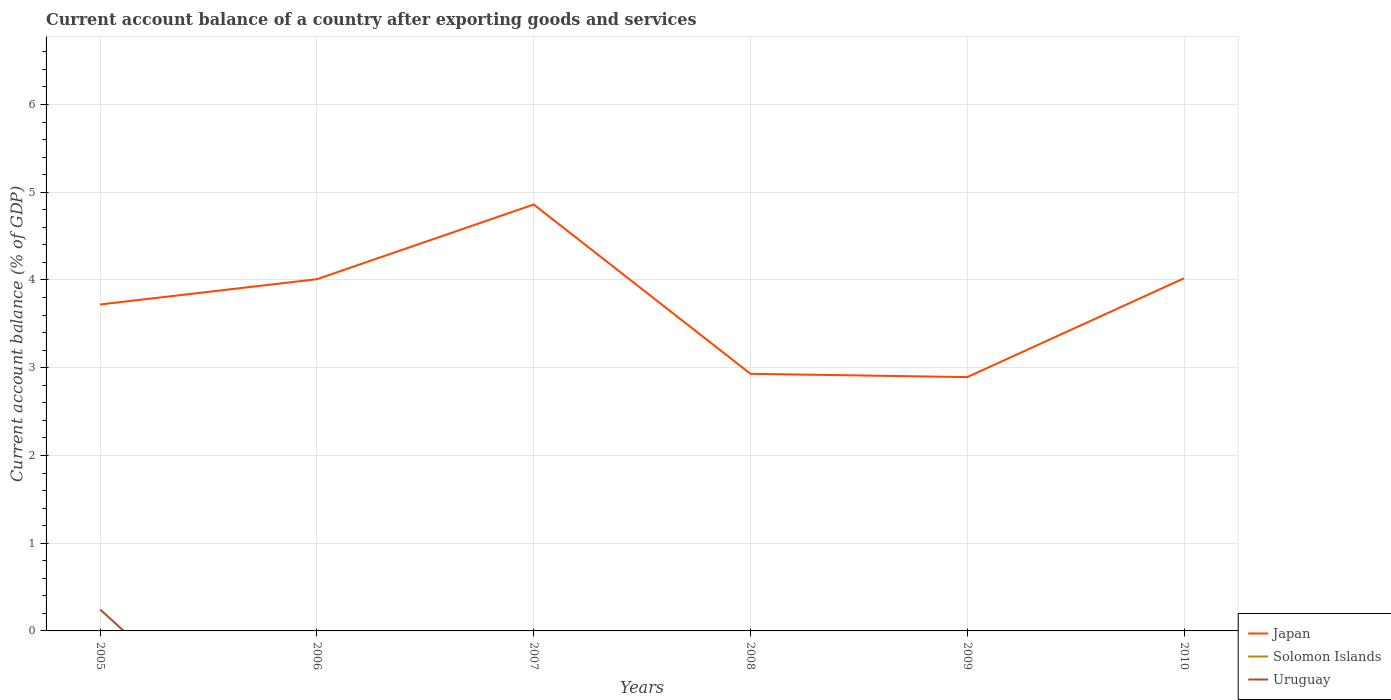How many different coloured lines are there?
Keep it short and to the point. 2. Does the line corresponding to Uruguay intersect with the line corresponding to Solomon Islands?
Your answer should be compact. No. Across all years, what is the maximum account balance in Uruguay?
Ensure brevity in your answer.  0. What is the total account balance in Japan in the graph?
Provide a succinct answer. 0.04. What is the difference between the highest and the second highest account balance in Japan?
Offer a very short reply. 1.97. Does the graph contain any zero values?
Your answer should be very brief. Yes. Does the graph contain grids?
Make the answer very short. Yes. How are the legend labels stacked?
Your answer should be compact. Vertical. What is the title of the graph?
Provide a short and direct response. Current account balance of a country after exporting goods and services. What is the label or title of the Y-axis?
Give a very brief answer. Current account balance (% of GDP). What is the Current account balance (% of GDP) in Japan in 2005?
Ensure brevity in your answer.  3.72. What is the Current account balance (% of GDP) in Uruguay in 2005?
Offer a very short reply. 0.24. What is the Current account balance (% of GDP) of Japan in 2006?
Ensure brevity in your answer.  4.01. What is the Current account balance (% of GDP) of Solomon Islands in 2006?
Give a very brief answer. 0. What is the Current account balance (% of GDP) in Uruguay in 2006?
Keep it short and to the point. 0. What is the Current account balance (% of GDP) in Japan in 2007?
Provide a succinct answer. 4.86. What is the Current account balance (% of GDP) in Uruguay in 2007?
Your response must be concise. 0. What is the Current account balance (% of GDP) in Japan in 2008?
Offer a terse response. 2.93. What is the Current account balance (% of GDP) in Japan in 2009?
Provide a succinct answer. 2.89. What is the Current account balance (% of GDP) in Uruguay in 2009?
Your answer should be very brief. 0. What is the Current account balance (% of GDP) of Japan in 2010?
Ensure brevity in your answer.  4.02. Across all years, what is the maximum Current account balance (% of GDP) of Japan?
Offer a terse response. 4.86. Across all years, what is the maximum Current account balance (% of GDP) in Uruguay?
Provide a succinct answer. 0.24. Across all years, what is the minimum Current account balance (% of GDP) of Japan?
Make the answer very short. 2.89. Across all years, what is the minimum Current account balance (% of GDP) in Uruguay?
Keep it short and to the point. 0. What is the total Current account balance (% of GDP) of Japan in the graph?
Give a very brief answer. 22.43. What is the total Current account balance (% of GDP) in Solomon Islands in the graph?
Offer a very short reply. 0. What is the total Current account balance (% of GDP) in Uruguay in the graph?
Your answer should be very brief. 0.24. What is the difference between the Current account balance (% of GDP) in Japan in 2005 and that in 2006?
Provide a succinct answer. -0.29. What is the difference between the Current account balance (% of GDP) of Japan in 2005 and that in 2007?
Provide a short and direct response. -1.14. What is the difference between the Current account balance (% of GDP) in Japan in 2005 and that in 2008?
Your answer should be very brief. 0.79. What is the difference between the Current account balance (% of GDP) in Japan in 2005 and that in 2009?
Your answer should be compact. 0.83. What is the difference between the Current account balance (% of GDP) of Japan in 2005 and that in 2010?
Offer a terse response. -0.3. What is the difference between the Current account balance (% of GDP) of Japan in 2006 and that in 2007?
Ensure brevity in your answer.  -0.85. What is the difference between the Current account balance (% of GDP) of Japan in 2006 and that in 2008?
Ensure brevity in your answer.  1.08. What is the difference between the Current account balance (% of GDP) in Japan in 2006 and that in 2009?
Keep it short and to the point. 1.12. What is the difference between the Current account balance (% of GDP) in Japan in 2006 and that in 2010?
Provide a short and direct response. -0.01. What is the difference between the Current account balance (% of GDP) in Japan in 2007 and that in 2008?
Your response must be concise. 1.93. What is the difference between the Current account balance (% of GDP) in Japan in 2007 and that in 2009?
Give a very brief answer. 1.97. What is the difference between the Current account balance (% of GDP) in Japan in 2007 and that in 2010?
Your answer should be very brief. 0.84. What is the difference between the Current account balance (% of GDP) in Japan in 2008 and that in 2009?
Offer a terse response. 0.04. What is the difference between the Current account balance (% of GDP) in Japan in 2008 and that in 2010?
Offer a very short reply. -1.09. What is the difference between the Current account balance (% of GDP) in Japan in 2009 and that in 2010?
Your response must be concise. -1.13. What is the average Current account balance (% of GDP) in Japan per year?
Provide a succinct answer. 3.74. What is the average Current account balance (% of GDP) in Uruguay per year?
Your response must be concise. 0.04. In the year 2005, what is the difference between the Current account balance (% of GDP) of Japan and Current account balance (% of GDP) of Uruguay?
Your answer should be very brief. 3.48. What is the ratio of the Current account balance (% of GDP) in Japan in 2005 to that in 2006?
Give a very brief answer. 0.93. What is the ratio of the Current account balance (% of GDP) of Japan in 2005 to that in 2007?
Ensure brevity in your answer.  0.77. What is the ratio of the Current account balance (% of GDP) in Japan in 2005 to that in 2008?
Your answer should be very brief. 1.27. What is the ratio of the Current account balance (% of GDP) of Japan in 2005 to that in 2009?
Make the answer very short. 1.29. What is the ratio of the Current account balance (% of GDP) of Japan in 2005 to that in 2010?
Ensure brevity in your answer.  0.93. What is the ratio of the Current account balance (% of GDP) of Japan in 2006 to that in 2007?
Ensure brevity in your answer.  0.82. What is the ratio of the Current account balance (% of GDP) of Japan in 2006 to that in 2008?
Provide a succinct answer. 1.37. What is the ratio of the Current account balance (% of GDP) of Japan in 2006 to that in 2009?
Provide a succinct answer. 1.39. What is the ratio of the Current account balance (% of GDP) of Japan in 2007 to that in 2008?
Your answer should be very brief. 1.66. What is the ratio of the Current account balance (% of GDP) in Japan in 2007 to that in 2009?
Provide a short and direct response. 1.68. What is the ratio of the Current account balance (% of GDP) in Japan in 2007 to that in 2010?
Provide a short and direct response. 1.21. What is the ratio of the Current account balance (% of GDP) of Japan in 2008 to that in 2009?
Your answer should be compact. 1.01. What is the ratio of the Current account balance (% of GDP) of Japan in 2008 to that in 2010?
Keep it short and to the point. 0.73. What is the ratio of the Current account balance (% of GDP) in Japan in 2009 to that in 2010?
Ensure brevity in your answer.  0.72. What is the difference between the highest and the second highest Current account balance (% of GDP) in Japan?
Offer a very short reply. 0.84. What is the difference between the highest and the lowest Current account balance (% of GDP) of Japan?
Your answer should be compact. 1.97. What is the difference between the highest and the lowest Current account balance (% of GDP) of Uruguay?
Your answer should be very brief. 0.24. 